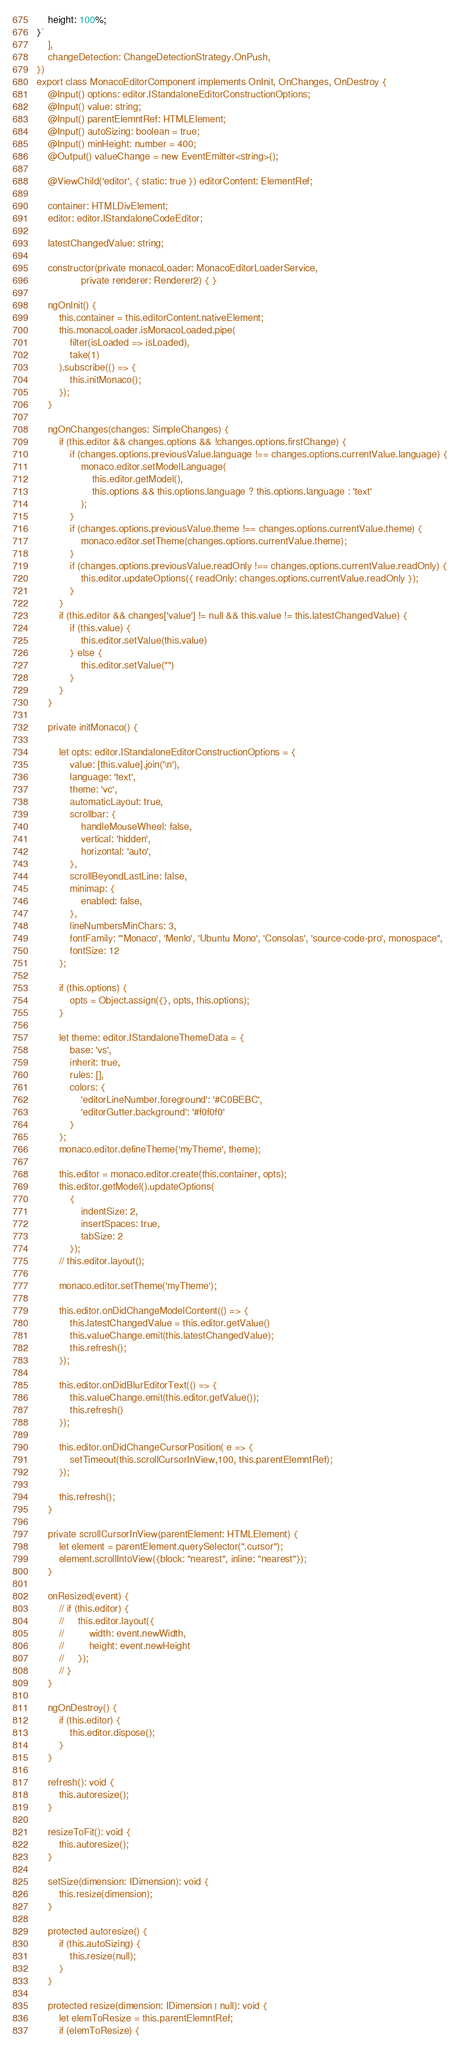<code> <loc_0><loc_0><loc_500><loc_500><_TypeScript_>	height: 100%;
}`
    ],
    changeDetection: ChangeDetectionStrategy.OnPush,
})
export class MonacoEditorComponent implements OnInit, OnChanges, OnDestroy {
    @Input() options: editor.IStandaloneEditorConstructionOptions;
    @Input() value: string;
    @Input() parentElemntRef: HTMLElement;
    @Input() autoSizing: boolean = true;
    @Input() minHeight: number = 400;
    @Output() valueChange = new EventEmitter<string>();

    @ViewChild('editor', { static: true }) editorContent: ElementRef;

    container: HTMLDivElement;
    editor: editor.IStandaloneCodeEditor;

    latestChangedValue: string;

    constructor(private monacoLoader: MonacoEditorLoaderService,
                private renderer: Renderer2) { }

    ngOnInit() {
        this.container = this.editorContent.nativeElement;
        this.monacoLoader.isMonacoLoaded.pipe(
            filter(isLoaded => isLoaded),
            take(1)
        ).subscribe(() => {
            this.initMonaco();
        });
    }

    ngOnChanges(changes: SimpleChanges) {
        if (this.editor && changes.options && !changes.options.firstChange) {
            if (changes.options.previousValue.language !== changes.options.currentValue.language) {
                monaco.editor.setModelLanguage(
                    this.editor.getModel(),
                    this.options && this.options.language ? this.options.language : 'text'
                );
            }
            if (changes.options.previousValue.theme !== changes.options.currentValue.theme) {
                monaco.editor.setTheme(changes.options.currentValue.theme);
            }
            if (changes.options.previousValue.readOnly !== changes.options.currentValue.readOnly) {
                this.editor.updateOptions({ readOnly: changes.options.currentValue.readOnly });
            }
        }
        if (this.editor && changes['value'] != null && this.value != this.latestChangedValue) {
            if (this.value) {
                this.editor.setValue(this.value)
            } else {
                this.editor.setValue("")
            }
        }
    }

    private initMonaco() {

        let opts: editor.IStandaloneEditorConstructionOptions = {
            value: [this.value].join('\n'),
            language: 'text',
            theme: 'vc',
            automaticLayout: true,
            scrollbar: {
                handleMouseWheel: false,
                vertical: 'hidden',
                horizontal: 'auto',
            },
            scrollBeyondLastLine: false,
            minimap: {
                enabled: false,
            },
            lineNumbersMinChars: 3,
            fontFamily: "'Monaco', 'Menlo', 'Ubuntu Mono', 'Consolas', 'source-code-pro', monospace",
            fontSize: 12
        };

        if (this.options) {
            opts = Object.assign({}, opts, this.options);
        }

        let theme: editor.IStandaloneThemeData = {
            base: 'vs',
            inherit: true,
            rules: [],
            colors: {
                'editorLineNumber.foreground': '#C0BEBC',
                'editorGutter.background': '#f0f0f0'
            }
        };
        monaco.editor.defineTheme('myTheme', theme);

        this.editor = monaco.editor.create(this.container, opts);
        this.editor.getModel().updateOptions(
            {
                indentSize: 2,
                insertSpaces: true,
                tabSize: 2
            });
        // this.editor.layout();

        monaco.editor.setTheme('myTheme');

        this.editor.onDidChangeModelContent(() => {
            this.latestChangedValue = this.editor.getValue()
            this.valueChange.emit(this.latestChangedValue);
            this.refresh();
        });

        this.editor.onDidBlurEditorText(() => {
            this.valueChange.emit(this.editor.getValue());
            this.refresh()
        });

        this.editor.onDidChangeCursorPosition( e => {
            setTimeout(this.scrollCursorInView,100, this.parentElemntRef);
        });

        this.refresh();
    }

    private scrollCursorInView(parentElement: HTMLElement) {
        let element = parentElement.querySelector(".cursor");
        element.scrollIntoView({block: "nearest", inline: "nearest"});
    }

    onResized(event) {
        // if (this.editor) {
        //     this.editor.layout({
        //         width: event.newWidth,
        //         height: event.newHeight
        //     });
        // }
    }

    ngOnDestroy() {
        if (this.editor) {
            this.editor.dispose();
        }
    }

    refresh(): void {
        this.autoresize();
    }

    resizeToFit(): void {
        this.autoresize();
    }

    setSize(dimension: IDimension): void {
        this.resize(dimension);
    }

    protected autoresize() {
        if (this.autoSizing) {
            this.resize(null);
        }
    }

    protected resize(dimension: IDimension | null): void {
        let elemToResize = this.parentElemntRef;
        if (elemToResize) {</code> 